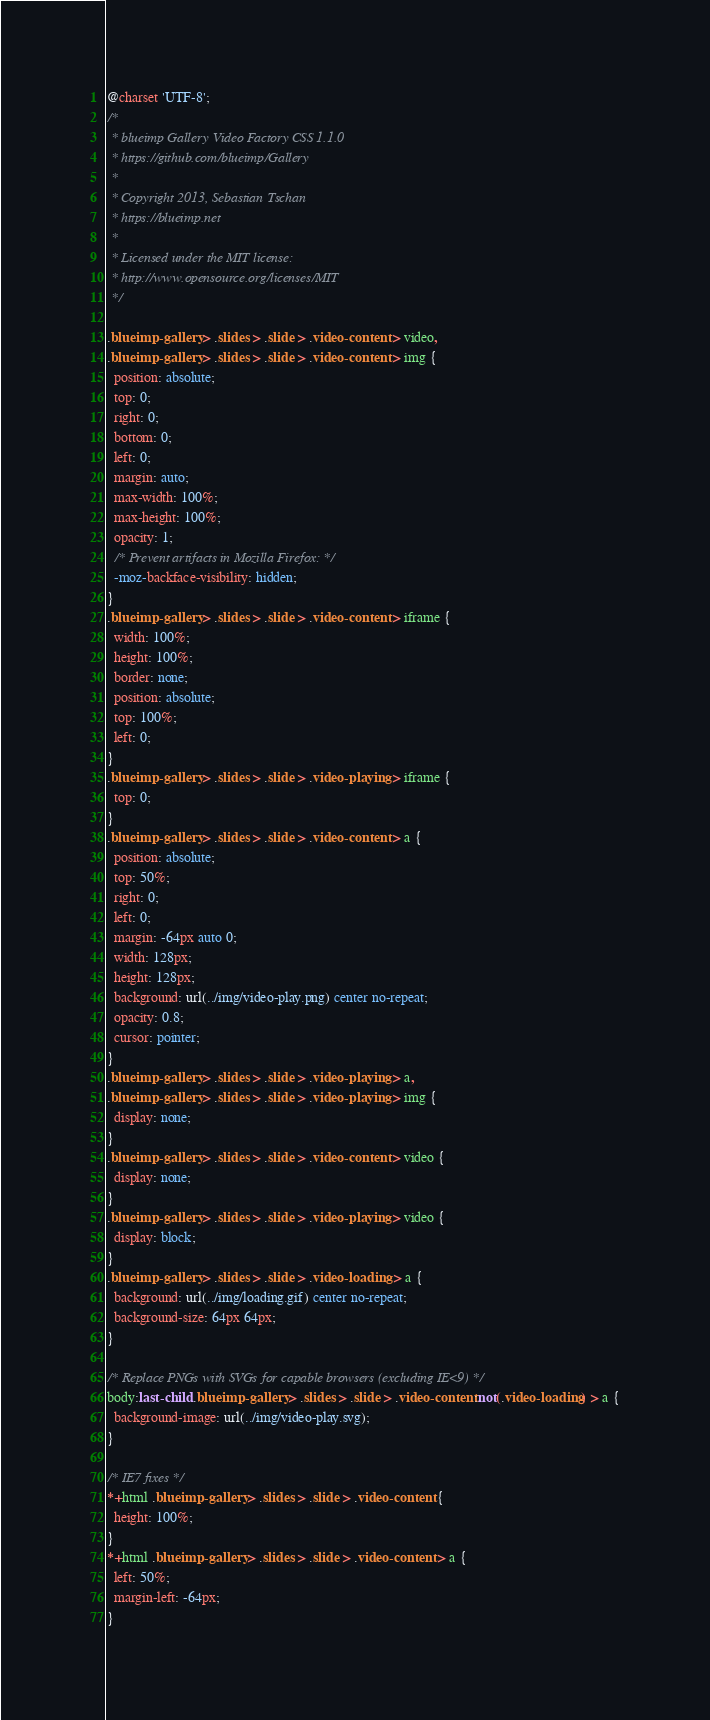Convert code to text. <code><loc_0><loc_0><loc_500><loc_500><_CSS_>@charset 'UTF-8';
/*
 * blueimp Gallery Video Factory CSS 1.1.0
 * https://github.com/blueimp/Gallery
 *
 * Copyright 2013, Sebastian Tschan
 * https://blueimp.net
 *
 * Licensed under the MIT license:
 * http://www.opensource.org/licenses/MIT
 */

.blueimp-gallery > .slides > .slide > .video-content > video,
.blueimp-gallery > .slides > .slide > .video-content > img {
  position: absolute;
  top: 0;
  right: 0;
  bottom: 0;
  left: 0;
  margin: auto;
  max-width: 100%;
  max-height: 100%;
  opacity: 1;
  /* Prevent artifacts in Mozilla Firefox: */
  -moz-backface-visibility: hidden;
}
.blueimp-gallery > .slides > .slide > .video-content > iframe {
  width: 100%;
  height: 100%;
  border: none;
  position: absolute;
  top: 100%;
  left: 0;
}
.blueimp-gallery > .slides > .slide > .video-playing > iframe {
  top: 0;
}
.blueimp-gallery > .slides > .slide > .video-content > a {
  position: absolute;
  top: 50%;
  right: 0;
  left: 0;
  margin: -64px auto 0;
  width: 128px;
  height: 128px;
  background: url(../img/video-play.png) center no-repeat;
  opacity: 0.8;
  cursor: pointer;
}
.blueimp-gallery > .slides > .slide > .video-playing > a,
.blueimp-gallery > .slides > .slide > .video-playing > img {
  display: none;
}
.blueimp-gallery > .slides > .slide > .video-content > video {
  display: none;
}
.blueimp-gallery > .slides > .slide > .video-playing > video {
  display: block;
}
.blueimp-gallery > .slides > .slide > .video-loading > a {
  background: url(../img/loading.gif) center no-repeat;
  background-size: 64px 64px;
}

/* Replace PNGs with SVGs for capable browsers (excluding IE<9) */
body:last-child .blueimp-gallery > .slides > .slide > .video-content:not(.video-loading) > a {
  background-image: url(../img/video-play.svg);
}

/* IE7 fixes */
*+html .blueimp-gallery > .slides > .slide > .video-content {
  height: 100%;
}
*+html .blueimp-gallery > .slides > .slide > .video-content > a {
  left: 50%;
  margin-left: -64px;
}
</code> 